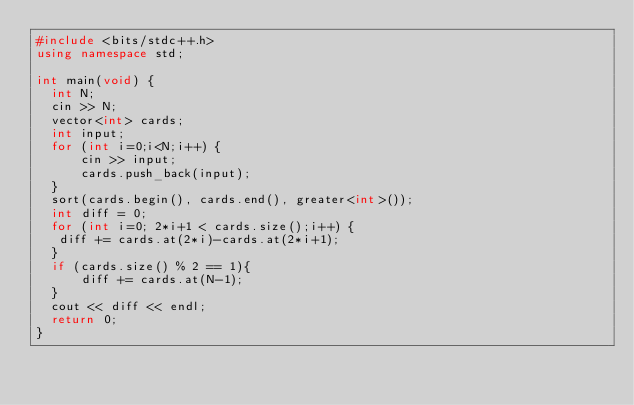Convert code to text. <code><loc_0><loc_0><loc_500><loc_500><_C++_>#include <bits/stdc++.h>
using namespace std;

int main(void) {
  int N;
  cin >> N;
  vector<int> cards;
  int input;
  for (int i=0;i<N;i++) {
      cin >> input;
      cards.push_back(input);
  }
  sort(cards.begin(), cards.end(), greater<int>());
  int diff = 0;
  for (int i=0; 2*i+1 < cards.size();i++) {
   diff += cards.at(2*i)-cards.at(2*i+1);
  }
  if (cards.size() % 2 == 1){
      diff += cards.at(N-1);
  }
  cout << diff << endl;
  return 0;
}</code> 